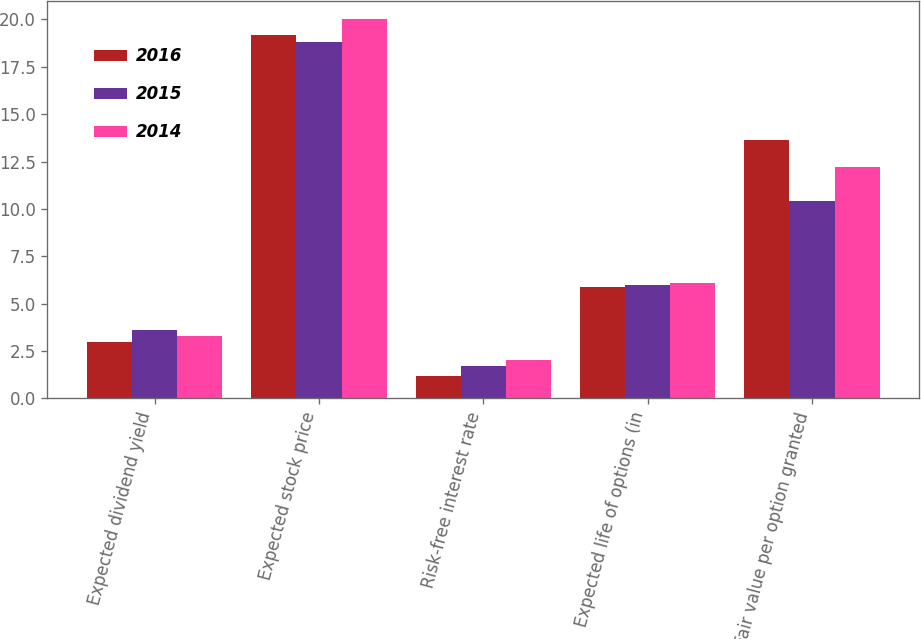<chart> <loc_0><loc_0><loc_500><loc_500><stacked_bar_chart><ecel><fcel>Expected dividend yield<fcel>Expected stock price<fcel>Risk-free interest rate<fcel>Expected life of options (in<fcel>Fair value per option granted<nl><fcel>2016<fcel>3<fcel>19.2<fcel>1.2<fcel>5.9<fcel>13.65<nl><fcel>2015<fcel>3.6<fcel>18.8<fcel>1.7<fcel>6<fcel>10.43<nl><fcel>2014<fcel>3.3<fcel>20<fcel>2<fcel>6.1<fcel>12.23<nl></chart> 